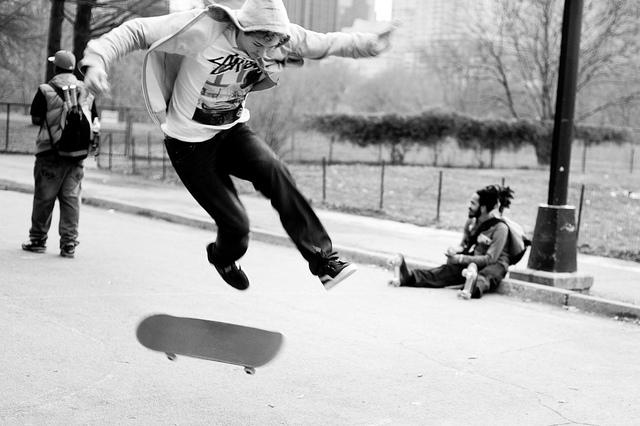What is this person riding?
Concise answer only. Skateboard. What is the man doing?
Keep it brief. Skateboarding. What is the man in the background doing?
Write a very short answer. Sitting. Where is the person sitting?
Keep it brief. Curb. What piece of outerwear is the skateboarder wearing?
Keep it brief. Hoodie. 